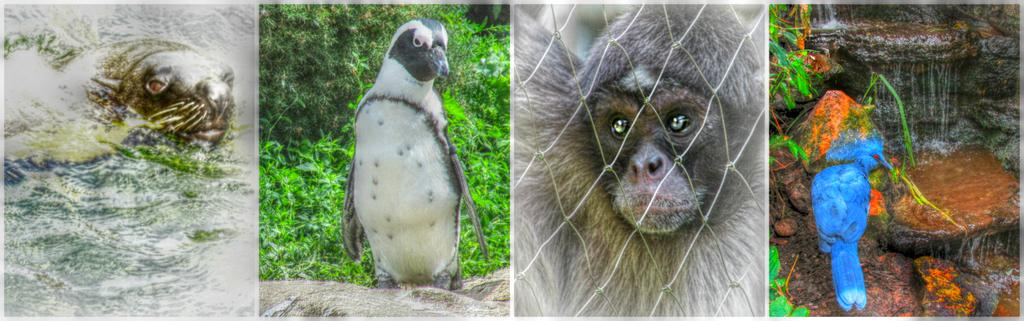What type of artwork is the image? The image is a collage. How many birds are present in the image? There are two birds in the image. How many animals are present in the image? There are two animals in the image. What natural element can be seen in the image? Water is visible in the image. What type of vegetation is present in the image? There are plants in the image. What type of inorganic material is present in the image? There are stones in the image. What type of barrier is present in the image? There is a metal grill fence in the image. What type of net is used to catch the fish in the image? There are no fish or nets present in the image. What type of poison is being used to control the pests in the image? There is no mention of pests or poison in the image. What type of chalk is being used to draw on the fence in the image? There is no chalk or drawing activity present in the image. 